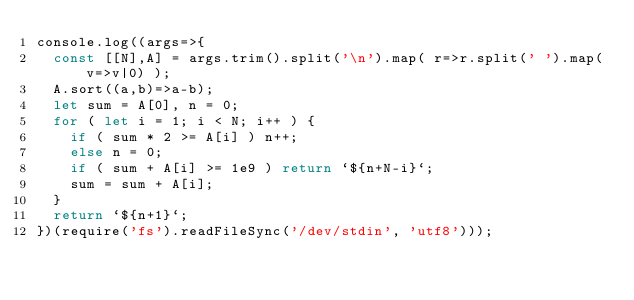Convert code to text. <code><loc_0><loc_0><loc_500><loc_500><_JavaScript_>console.log((args=>{
  const [[N],A] = args.trim().split('\n').map( r=>r.split(' ').map(v=>v|0) );
  A.sort((a,b)=>a-b);
  let sum = A[0], n = 0;
  for ( let i = 1; i < N; i++ ) {
    if ( sum * 2 >= A[i] ) n++;
    else n = 0;
    if ( sum + A[i] >= 1e9 ) return `${n+N-i}`;
    sum = sum + A[i];
  }
  return `${n+1}`;
})(require('fs').readFileSync('/dev/stdin', 'utf8')));
</code> 